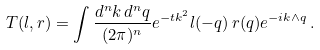<formula> <loc_0><loc_0><loc_500><loc_500>T ( l , r ) = \int \frac { d ^ { n } k \, d ^ { n } q } { ( 2 \pi ) ^ { n } } e ^ { - t k ^ { 2 } } l ( - q ) \, r ( q ) e ^ { - i k \wedge q } \, .</formula> 